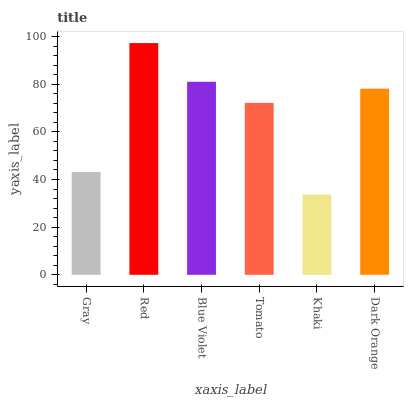Is Khaki the minimum?
Answer yes or no. Yes. Is Red the maximum?
Answer yes or no. Yes. Is Blue Violet the minimum?
Answer yes or no. No. Is Blue Violet the maximum?
Answer yes or no. No. Is Red greater than Blue Violet?
Answer yes or no. Yes. Is Blue Violet less than Red?
Answer yes or no. Yes. Is Blue Violet greater than Red?
Answer yes or no. No. Is Red less than Blue Violet?
Answer yes or no. No. Is Dark Orange the high median?
Answer yes or no. Yes. Is Tomato the low median?
Answer yes or no. Yes. Is Blue Violet the high median?
Answer yes or no. No. Is Gray the low median?
Answer yes or no. No. 